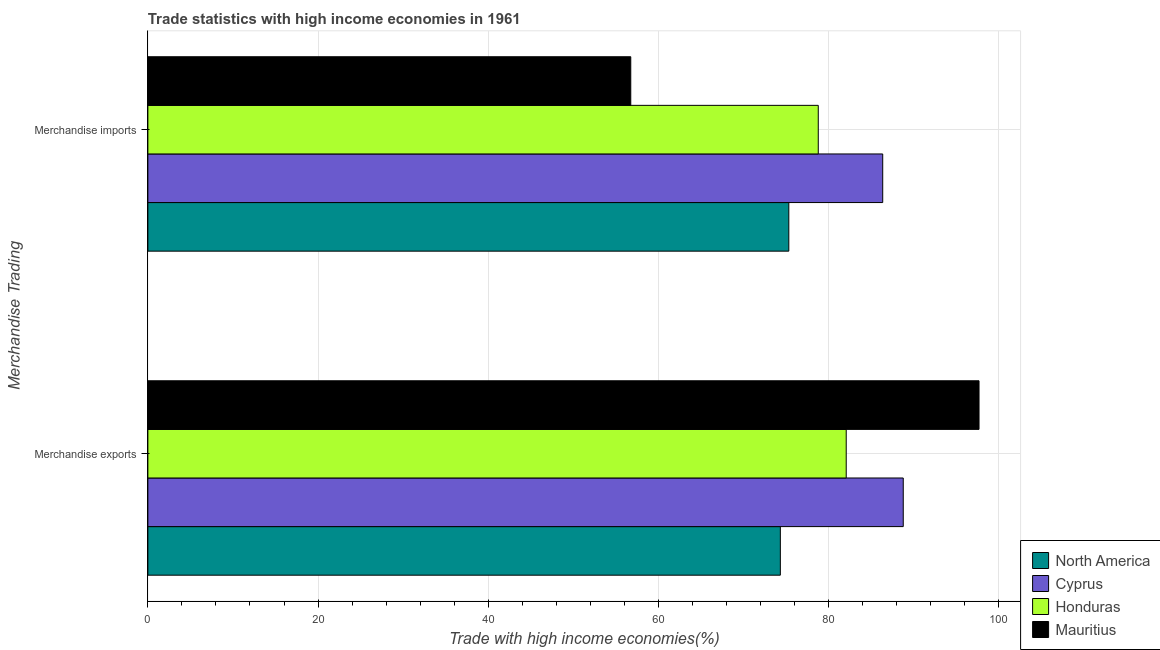How many different coloured bars are there?
Offer a very short reply. 4. Are the number of bars per tick equal to the number of legend labels?
Keep it short and to the point. Yes. How many bars are there on the 1st tick from the bottom?
Make the answer very short. 4. What is the label of the 2nd group of bars from the top?
Provide a succinct answer. Merchandise exports. What is the merchandise imports in Mauritius?
Keep it short and to the point. 56.75. Across all countries, what is the maximum merchandise imports?
Make the answer very short. 86.36. Across all countries, what is the minimum merchandise exports?
Provide a succinct answer. 74.33. In which country was the merchandise exports maximum?
Make the answer very short. Mauritius. What is the total merchandise imports in the graph?
Ensure brevity in your answer.  297.23. What is the difference between the merchandise exports in North America and that in Honduras?
Make the answer very short. -7.74. What is the difference between the merchandise imports in Cyprus and the merchandise exports in Mauritius?
Your response must be concise. -11.32. What is the average merchandise imports per country?
Keep it short and to the point. 74.31. What is the difference between the merchandise exports and merchandise imports in Cyprus?
Your response must be concise. 2.41. In how many countries, is the merchandise imports greater than 52 %?
Your response must be concise. 4. What is the ratio of the merchandise exports in Cyprus to that in Honduras?
Your answer should be very brief. 1.08. What does the 2nd bar from the top in Merchandise imports represents?
Keep it short and to the point. Honduras. What does the 2nd bar from the bottom in Merchandise imports represents?
Make the answer very short. Cyprus. How many countries are there in the graph?
Provide a succinct answer. 4. Does the graph contain any zero values?
Your response must be concise. No. Does the graph contain grids?
Offer a terse response. Yes. Where does the legend appear in the graph?
Provide a short and direct response. Bottom right. How are the legend labels stacked?
Keep it short and to the point. Vertical. What is the title of the graph?
Make the answer very short. Trade statistics with high income economies in 1961. What is the label or title of the X-axis?
Keep it short and to the point. Trade with high income economies(%). What is the label or title of the Y-axis?
Your answer should be compact. Merchandise Trading. What is the Trade with high income economies(%) in North America in Merchandise exports?
Your answer should be very brief. 74.33. What is the Trade with high income economies(%) in Cyprus in Merchandise exports?
Your answer should be compact. 88.78. What is the Trade with high income economies(%) of Honduras in Merchandise exports?
Offer a very short reply. 82.07. What is the Trade with high income economies(%) of Mauritius in Merchandise exports?
Your answer should be very brief. 97.68. What is the Trade with high income economies(%) of North America in Merchandise imports?
Provide a short and direct response. 75.33. What is the Trade with high income economies(%) in Cyprus in Merchandise imports?
Ensure brevity in your answer.  86.36. What is the Trade with high income economies(%) of Honduras in Merchandise imports?
Keep it short and to the point. 78.79. What is the Trade with high income economies(%) in Mauritius in Merchandise imports?
Make the answer very short. 56.75. Across all Merchandise Trading, what is the maximum Trade with high income economies(%) in North America?
Make the answer very short. 75.33. Across all Merchandise Trading, what is the maximum Trade with high income economies(%) in Cyprus?
Offer a very short reply. 88.78. Across all Merchandise Trading, what is the maximum Trade with high income economies(%) of Honduras?
Your response must be concise. 82.07. Across all Merchandise Trading, what is the maximum Trade with high income economies(%) of Mauritius?
Offer a very short reply. 97.68. Across all Merchandise Trading, what is the minimum Trade with high income economies(%) in North America?
Your answer should be compact. 74.33. Across all Merchandise Trading, what is the minimum Trade with high income economies(%) of Cyprus?
Provide a short and direct response. 86.36. Across all Merchandise Trading, what is the minimum Trade with high income economies(%) in Honduras?
Provide a succinct answer. 78.79. Across all Merchandise Trading, what is the minimum Trade with high income economies(%) in Mauritius?
Provide a succinct answer. 56.75. What is the total Trade with high income economies(%) in North America in the graph?
Offer a very short reply. 149.66. What is the total Trade with high income economies(%) of Cyprus in the graph?
Ensure brevity in your answer.  175.14. What is the total Trade with high income economies(%) of Honduras in the graph?
Give a very brief answer. 160.86. What is the total Trade with high income economies(%) in Mauritius in the graph?
Ensure brevity in your answer.  154.43. What is the difference between the Trade with high income economies(%) in North America in Merchandise exports and that in Merchandise imports?
Ensure brevity in your answer.  -1. What is the difference between the Trade with high income economies(%) of Cyprus in Merchandise exports and that in Merchandise imports?
Give a very brief answer. 2.41. What is the difference between the Trade with high income economies(%) of Honduras in Merchandise exports and that in Merchandise imports?
Your answer should be very brief. 3.29. What is the difference between the Trade with high income economies(%) in Mauritius in Merchandise exports and that in Merchandise imports?
Your answer should be very brief. 40.93. What is the difference between the Trade with high income economies(%) in North America in Merchandise exports and the Trade with high income economies(%) in Cyprus in Merchandise imports?
Keep it short and to the point. -12.03. What is the difference between the Trade with high income economies(%) in North America in Merchandise exports and the Trade with high income economies(%) in Honduras in Merchandise imports?
Provide a short and direct response. -4.46. What is the difference between the Trade with high income economies(%) in North America in Merchandise exports and the Trade with high income economies(%) in Mauritius in Merchandise imports?
Offer a terse response. 17.58. What is the difference between the Trade with high income economies(%) of Cyprus in Merchandise exports and the Trade with high income economies(%) of Honduras in Merchandise imports?
Make the answer very short. 9.99. What is the difference between the Trade with high income economies(%) of Cyprus in Merchandise exports and the Trade with high income economies(%) of Mauritius in Merchandise imports?
Give a very brief answer. 32.02. What is the difference between the Trade with high income economies(%) of Honduras in Merchandise exports and the Trade with high income economies(%) of Mauritius in Merchandise imports?
Your answer should be compact. 25.32. What is the average Trade with high income economies(%) in North America per Merchandise Trading?
Provide a succinct answer. 74.83. What is the average Trade with high income economies(%) in Cyprus per Merchandise Trading?
Offer a terse response. 87.57. What is the average Trade with high income economies(%) of Honduras per Merchandise Trading?
Your response must be concise. 80.43. What is the average Trade with high income economies(%) of Mauritius per Merchandise Trading?
Offer a terse response. 77.22. What is the difference between the Trade with high income economies(%) of North America and Trade with high income economies(%) of Cyprus in Merchandise exports?
Your answer should be compact. -14.44. What is the difference between the Trade with high income economies(%) of North America and Trade with high income economies(%) of Honduras in Merchandise exports?
Ensure brevity in your answer.  -7.74. What is the difference between the Trade with high income economies(%) in North America and Trade with high income economies(%) in Mauritius in Merchandise exports?
Provide a succinct answer. -23.35. What is the difference between the Trade with high income economies(%) in Cyprus and Trade with high income economies(%) in Honduras in Merchandise exports?
Ensure brevity in your answer.  6.7. What is the difference between the Trade with high income economies(%) in Cyprus and Trade with high income economies(%) in Mauritius in Merchandise exports?
Ensure brevity in your answer.  -8.91. What is the difference between the Trade with high income economies(%) in Honduras and Trade with high income economies(%) in Mauritius in Merchandise exports?
Make the answer very short. -15.61. What is the difference between the Trade with high income economies(%) of North America and Trade with high income economies(%) of Cyprus in Merchandise imports?
Your answer should be very brief. -11.04. What is the difference between the Trade with high income economies(%) in North America and Trade with high income economies(%) in Honduras in Merchandise imports?
Provide a succinct answer. -3.46. What is the difference between the Trade with high income economies(%) of North America and Trade with high income economies(%) of Mauritius in Merchandise imports?
Your answer should be compact. 18.57. What is the difference between the Trade with high income economies(%) of Cyprus and Trade with high income economies(%) of Honduras in Merchandise imports?
Provide a succinct answer. 7.58. What is the difference between the Trade with high income economies(%) of Cyprus and Trade with high income economies(%) of Mauritius in Merchandise imports?
Keep it short and to the point. 29.61. What is the difference between the Trade with high income economies(%) in Honduras and Trade with high income economies(%) in Mauritius in Merchandise imports?
Your answer should be very brief. 22.04. What is the ratio of the Trade with high income economies(%) of North America in Merchandise exports to that in Merchandise imports?
Provide a succinct answer. 0.99. What is the ratio of the Trade with high income economies(%) of Cyprus in Merchandise exports to that in Merchandise imports?
Offer a very short reply. 1.03. What is the ratio of the Trade with high income economies(%) in Honduras in Merchandise exports to that in Merchandise imports?
Give a very brief answer. 1.04. What is the ratio of the Trade with high income economies(%) in Mauritius in Merchandise exports to that in Merchandise imports?
Make the answer very short. 1.72. What is the difference between the highest and the second highest Trade with high income economies(%) in North America?
Your answer should be very brief. 1. What is the difference between the highest and the second highest Trade with high income economies(%) in Cyprus?
Your answer should be compact. 2.41. What is the difference between the highest and the second highest Trade with high income economies(%) in Honduras?
Ensure brevity in your answer.  3.29. What is the difference between the highest and the second highest Trade with high income economies(%) of Mauritius?
Offer a terse response. 40.93. What is the difference between the highest and the lowest Trade with high income economies(%) of Cyprus?
Provide a succinct answer. 2.41. What is the difference between the highest and the lowest Trade with high income economies(%) in Honduras?
Make the answer very short. 3.29. What is the difference between the highest and the lowest Trade with high income economies(%) of Mauritius?
Your answer should be compact. 40.93. 